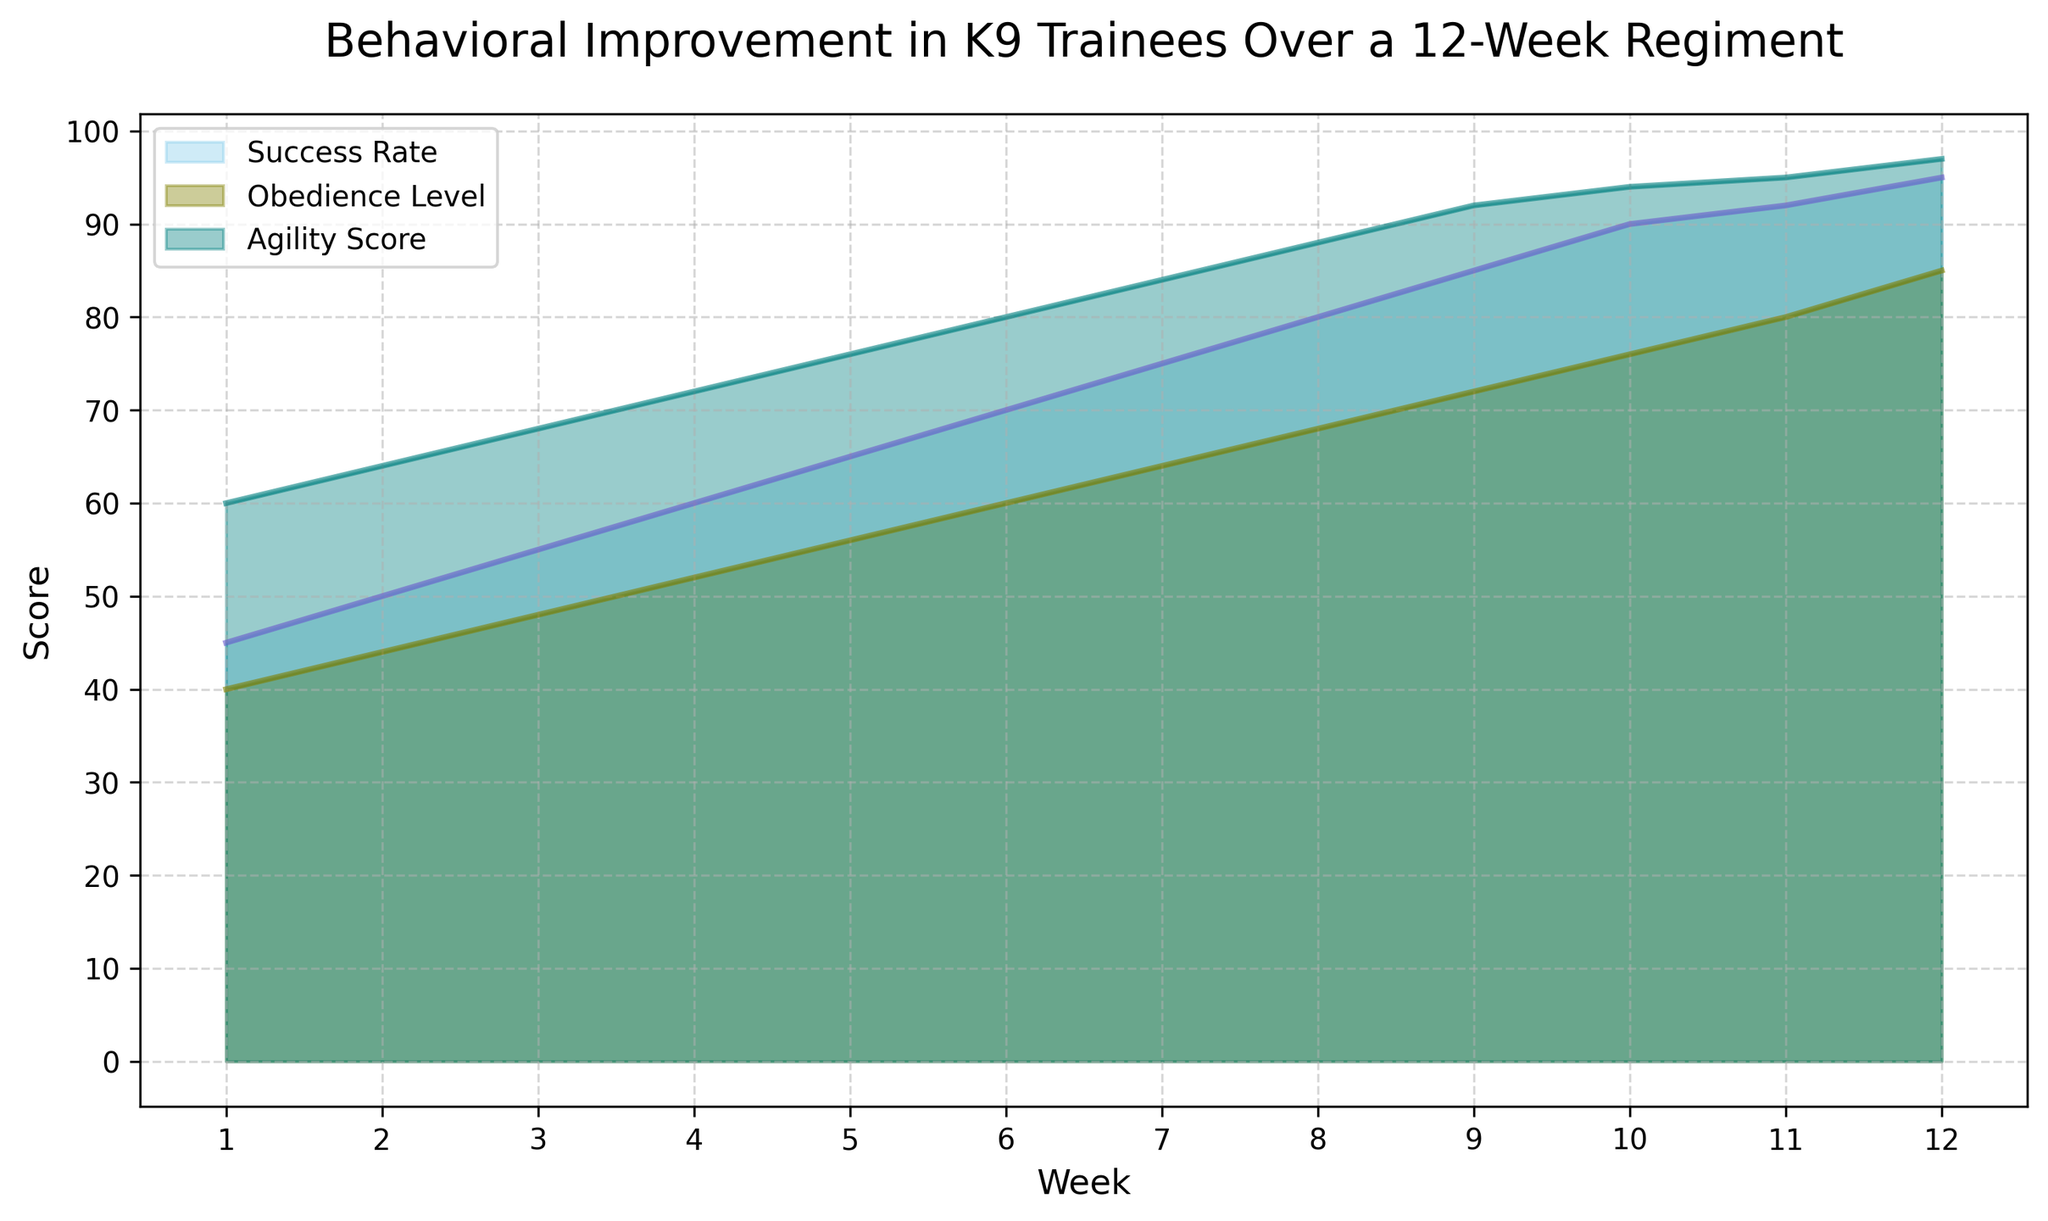What is the highest value observed for the Success Rate? The highest value for the Success Rate can be found by looking at the peak of the corresponding "skyblue" area, which is at Week 12 with a Success Rate of 95.
Answer: 95 At which week do Obedience Level and Agility Score reach their maximum values? To determine the maximum values, we observe the peaks of the "olive" area for Obedience Level and the "teal" area for Agility Score. For both Obedience Level and Agility Score, the maximum values are reached at Week 12.
Answer: Week 12 How much did the Success Rate improve from Week 1 to Week 12? The Success Rate at Week 1 is 45, and at Week 12 it is 95. The improvement is calculated by subtracting the initial value from the final value: 95 - 45 = 50.
Answer: 50 Which measure shows the highest growth over the 12-week period? By visually inspecting the differences in area heights from Week 1 to Week 12 for each measure: Success Rate grows from 45 to 95 (50 units), Obedience Level from 40 to 85 (45 units), and Agility Score from 60 to 97 (37 units). Success Rate shows the highest absolute growth.
Answer: Success Rate Compare Obedience Level and Agility Score at Week 6. Which one is higher, and by how much? At Week 6, the Obedience Level is at 60, while the Agility Score is at 80. To compare, we subtract Obedience Level from Agility Score: 80 - 60 = 20. Agility Score is higher by 20 units.
Answer: Agility Score by 20 Which visual representation has the smallest area: Success Rate, Obedience Level, or Agility Score? Visually inspecting the colored areas from Week 1 to Week 12, the smallest area is covered by "olive" (Obedience Level).
Answer: Obedience Level Between Weeks 8 and 10, which measure increases the most? To determine this, subtract the values at Week 8 from Week 10 for each measure: Success Rate (90 - 80 = 10), Obedience Level (76 - 68 = 8), Agility Score (94 - 88 = 6). The Success Rate increases the most by 10 units.
Answer: Success Rate What is the average value of the Agility Score over the 12-week period? Adding up the Agility Score values from Week 1 to Week 12 (60+64+68+72+76+80+84+88+92+94+95+97 = 970) and then dividing by the number of weeks (970 / 12), we get approximately 80.83.
Answer: 80.83 Does any measure plateau, and if so, during which weeks does this occur? By visually inspecting the plot, all measures show continuous improvement, and none of them plateau at any specific period. No plateaus are seen.
Answer: No 